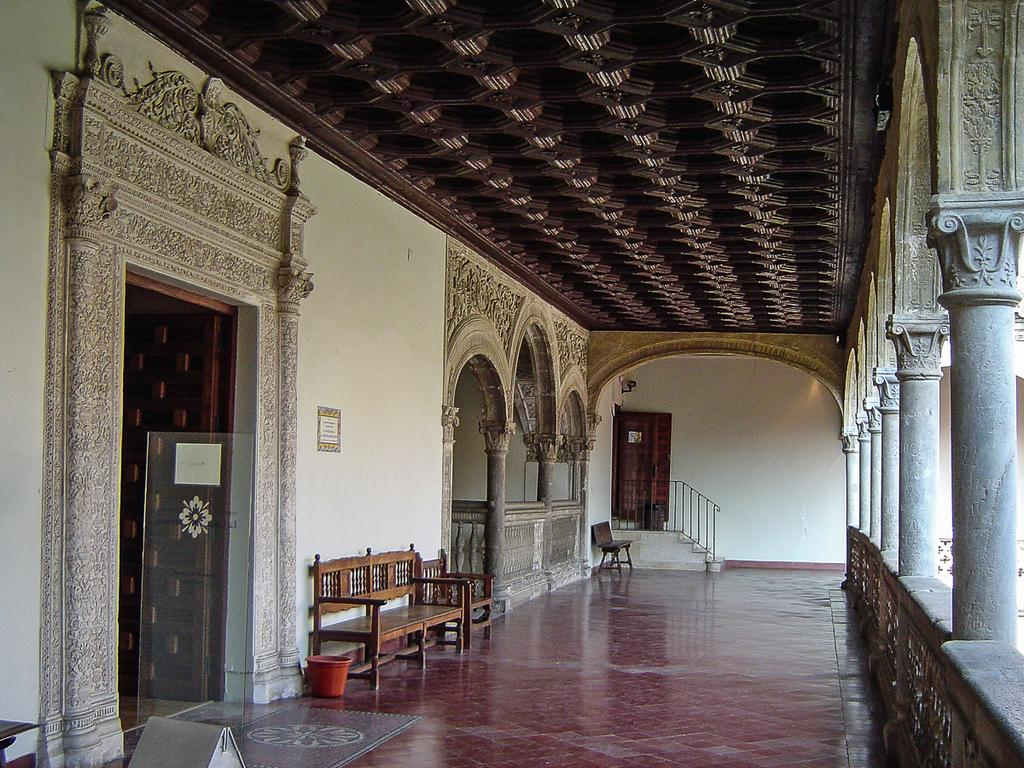What object can be seen in the image that is typically used for holding or carrying items? There is a bucket in the image. What piece of furniture is located in the center of the image? There is a bench in the center of the image. What type of seating is visible in the background of the image? There is a chair in the background of the image. What architectural feature can be seen in the background of the image? There are stairs in the background of the image. What type of opening is visible in the background of the image? There are doors in the background of the image. What structural element can be seen on the right side of the image? There are pillars on the right side of the image. What type of record can be seen on the bench in the image? There is no record present in the image; only a bucket, bench, chair, stairs, doors, and pillars are visible. What type of sheet is covering the pillars in the image? There is no sheet present in the image; the pillars are visible without any covering. 